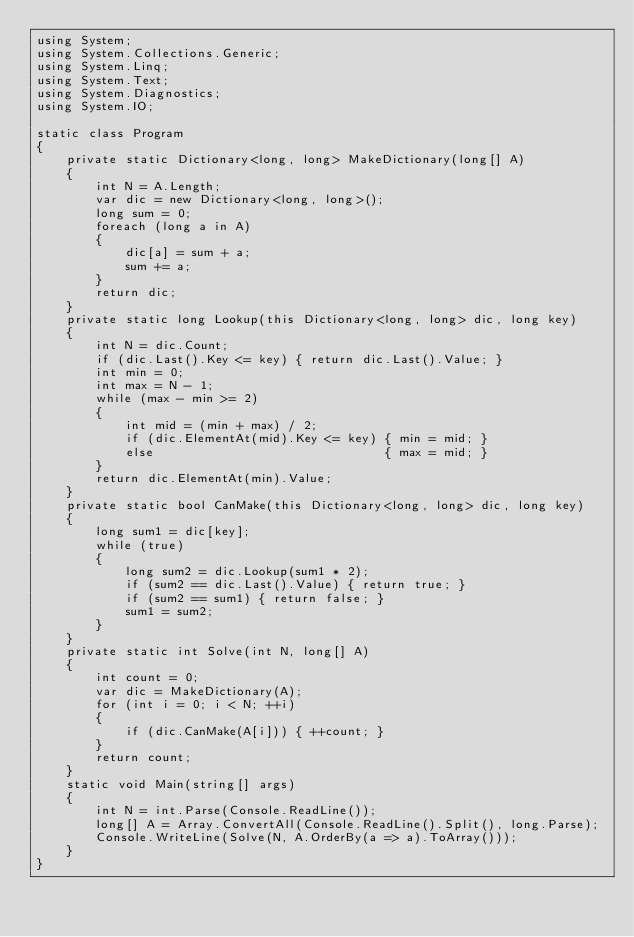<code> <loc_0><loc_0><loc_500><loc_500><_C#_>using System;
using System.Collections.Generic;
using System.Linq;
using System.Text;
using System.Diagnostics;
using System.IO;

static class Program
{
    private static Dictionary<long, long> MakeDictionary(long[] A)
    {
        int N = A.Length;
        var dic = new Dictionary<long, long>();
        long sum = 0;
        foreach (long a in A)
        {
            dic[a] = sum + a;
            sum += a;
        }
        return dic;
    }
    private static long Lookup(this Dictionary<long, long> dic, long key)
    {
        int N = dic.Count;
        if (dic.Last().Key <= key) { return dic.Last().Value; }
        int min = 0;
        int max = N - 1;
        while (max - min >= 2)
        {
            int mid = (min + max) / 2;
            if (dic.ElementAt(mid).Key <= key) { min = mid; }
            else                               { max = mid; }
        }
        return dic.ElementAt(min).Value;
    }
    private static bool CanMake(this Dictionary<long, long> dic, long key)
    {
        long sum1 = dic[key];
        while (true)
        {
            long sum2 = dic.Lookup(sum1 * 2);
            if (sum2 == dic.Last().Value) { return true; }
            if (sum2 == sum1) { return false; }
            sum1 = sum2;
        }
    }
    private static int Solve(int N, long[] A)
    {
        int count = 0;
        var dic = MakeDictionary(A);
        for (int i = 0; i < N; ++i)
        {
            if (dic.CanMake(A[i])) { ++count; }
        }
        return count;
    }
    static void Main(string[] args)
    {
        int N = int.Parse(Console.ReadLine());
        long[] A = Array.ConvertAll(Console.ReadLine().Split(), long.Parse);
        Console.WriteLine(Solve(N, A.OrderBy(a => a).ToArray()));
    }
}
</code> 